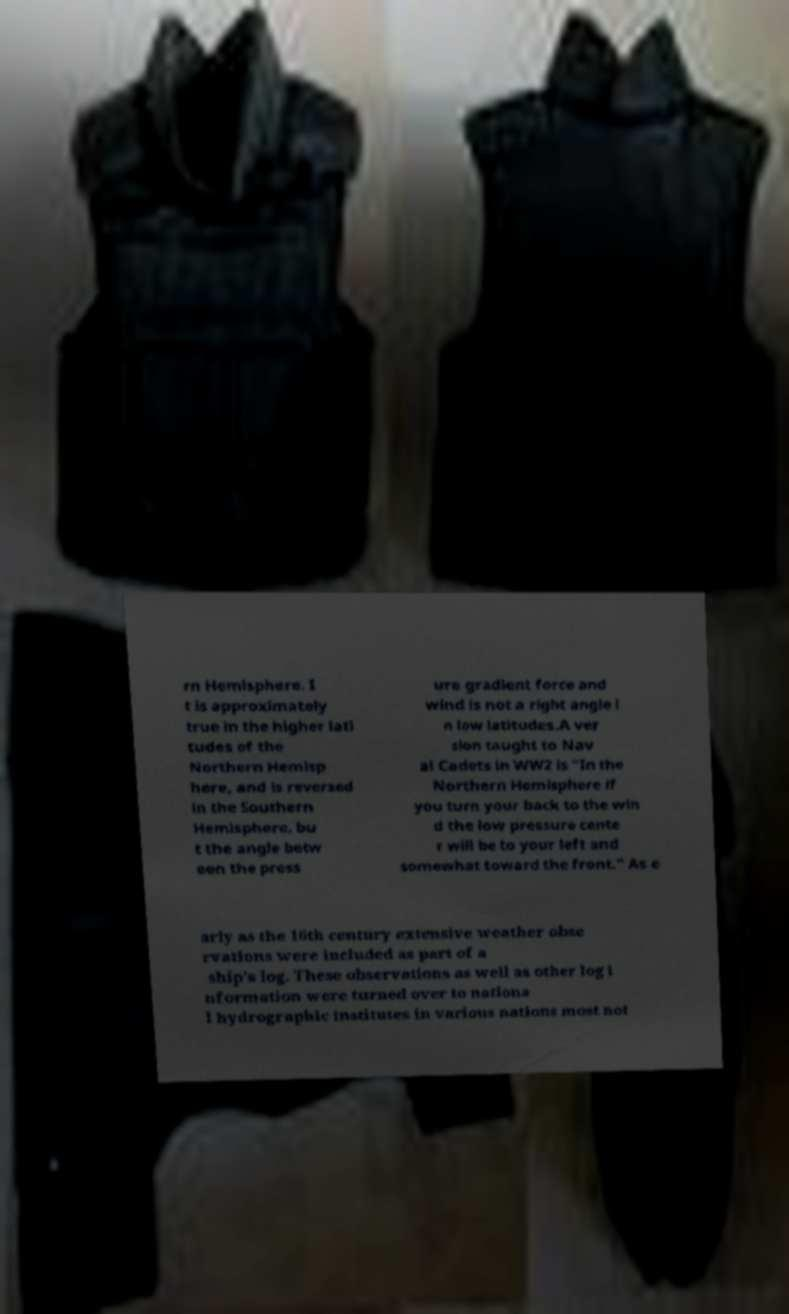Can you accurately transcribe the text from the provided image for me? rn Hemisphere. I t is approximately true in the higher lati tudes of the Northern Hemisp here, and is reversed in the Southern Hemisphere, bu t the angle betw een the press ure gradient force and wind is not a right angle i n low latitudes.A ver sion taught to Nav al Cadets in WW2 is "In the Northern Hemisphere if you turn your back to the win d the low pressure cente r will be to your left and somewhat toward the front." As e arly as the 16th century extensive weather obse rvations were included as part of a ship's log. These observations as well as other log i nformation were turned over to nationa l hydrographic institutes in various nations most not 